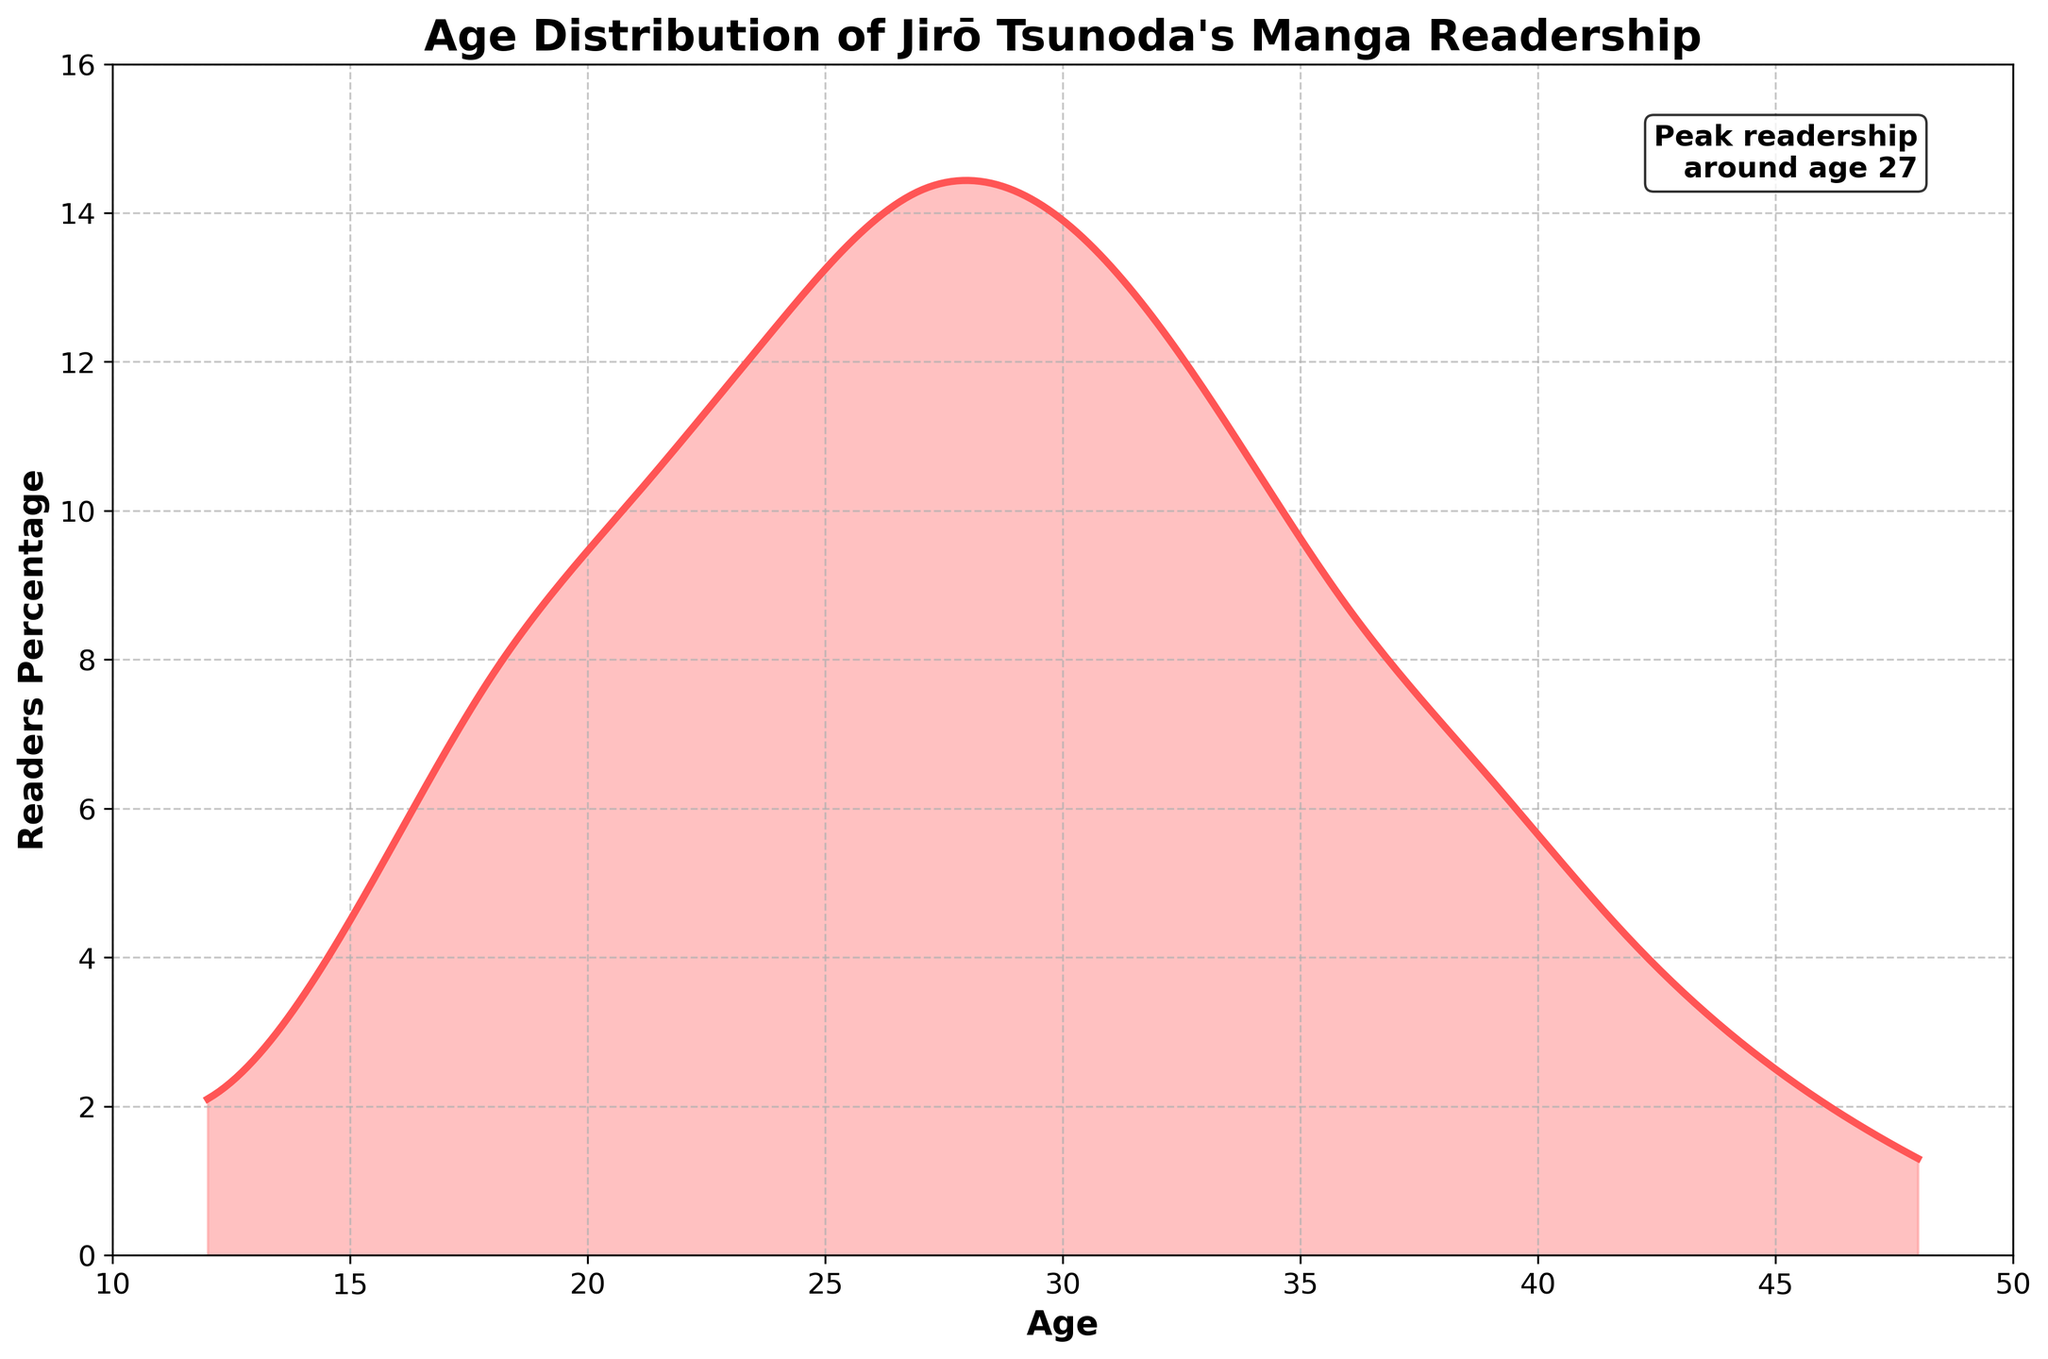What is the title of the plot? Look at the top of the plot, the title is usually displayed there. It reads: "Age Distribution of Jirō Tsunoda's Manga Readership".
Answer: Age Distribution of Jirō Tsunoda's Manga Readership What are the age ranges displayed on the x-axis? Check the labels on the x-axis to see the range of ages. It ranges from 10 to 50.
Answer: 10 to 50 In which age group is the peak readership observed? By observing the plot, the peak is the highest point on the density curve, which is annotated as "Peak readership around age 27".
Answer: Around age 27 How does the readership percentage change from ages 24 to 30? Observe the plot and notice how the density curve rises to its peak at around age 27 and then gradually decreases by age 30.
Answer: It increases until age 27 and then decreases Compare the readership percentages at ages 18 and 36. Locate these ages on the x-axis and compare the heights of the density curve at these points. At age 18, the percentage is higher than at age 36.
Answer: Higher at age 18 than at age 36 What color represents the area under the density curve? Notice the color used to fill the space under the density curve. It is a light red or pink shade.
Answer: Light red/pink What is the total readers' percentage between the ages of 21 and 30? Identify the percentages at these ages and sum them up. For ages 21, 24, 27, and 30, the percentages are 10.2, 12.5, 14.3, and 13.9 respectively. Summing these gives 50.9%.
Answer: 50.9% Is the readership more evenly distributed in younger or older age groups? Observe the density curve and notice how it has more variation in younger age groups (under 30) compared to older age groups (over 30), where it declines more steadily.
Answer: More variation in younger age groups What are the y-axis limits of the plot? Check the y-axis range from bottom to top. It ranges from 0 to 16.
Answer: 0 to 16 How does the density curve change as it moves towards age 48? Follow the curve from younger to older ages and observe the decline. It steadily decreases as it approaches age 48.
Answer: Steadily decreases 